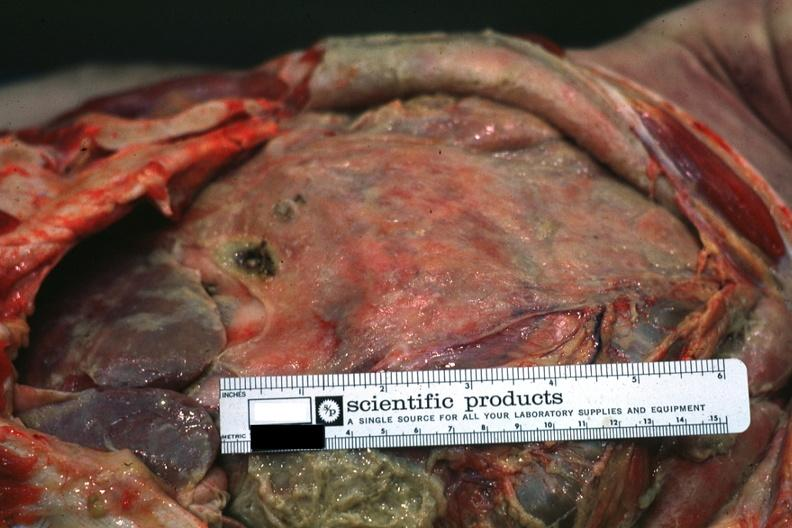what is present?
Answer the question using a single word or phrase. Peritoneum 